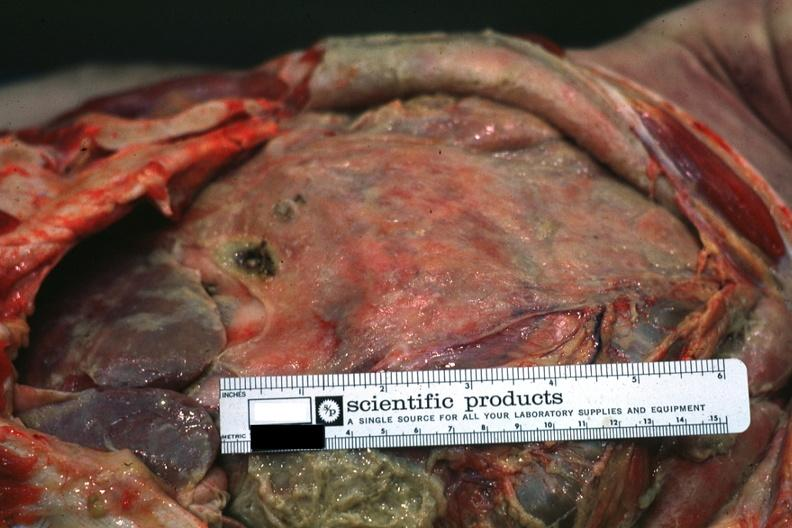what is present?
Answer the question using a single word or phrase. Peritoneum 